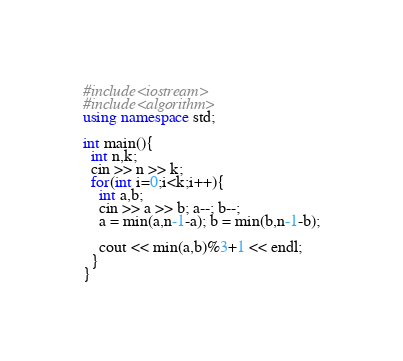Convert code to text. <code><loc_0><loc_0><loc_500><loc_500><_C++_>#include<iostream>
#include<algorithm>
using namespace std;

int main(){
  int n,k;
  cin >> n >> k;
  for(int i=0;i<k;i++){
    int a,b;
    cin >> a >> b; a--; b--;
    a = min(a,n-1-a); b = min(b,n-1-b);

    cout << min(a,b)%3+1 << endl;
  }
}</code> 